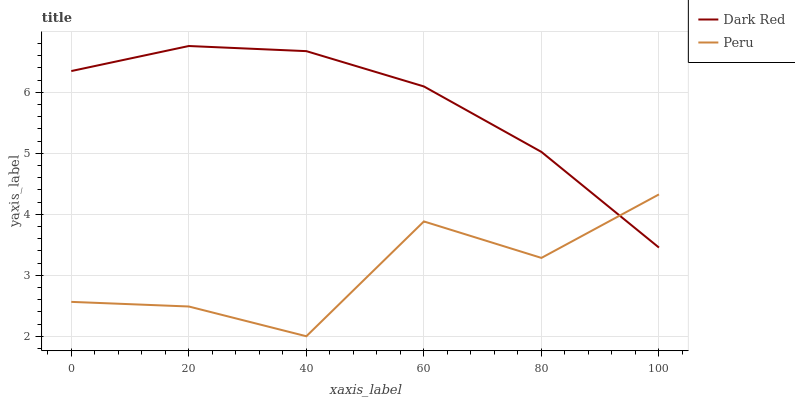Does Peru have the maximum area under the curve?
Answer yes or no. No. Is Peru the smoothest?
Answer yes or no. No. Does Peru have the highest value?
Answer yes or no. No. 